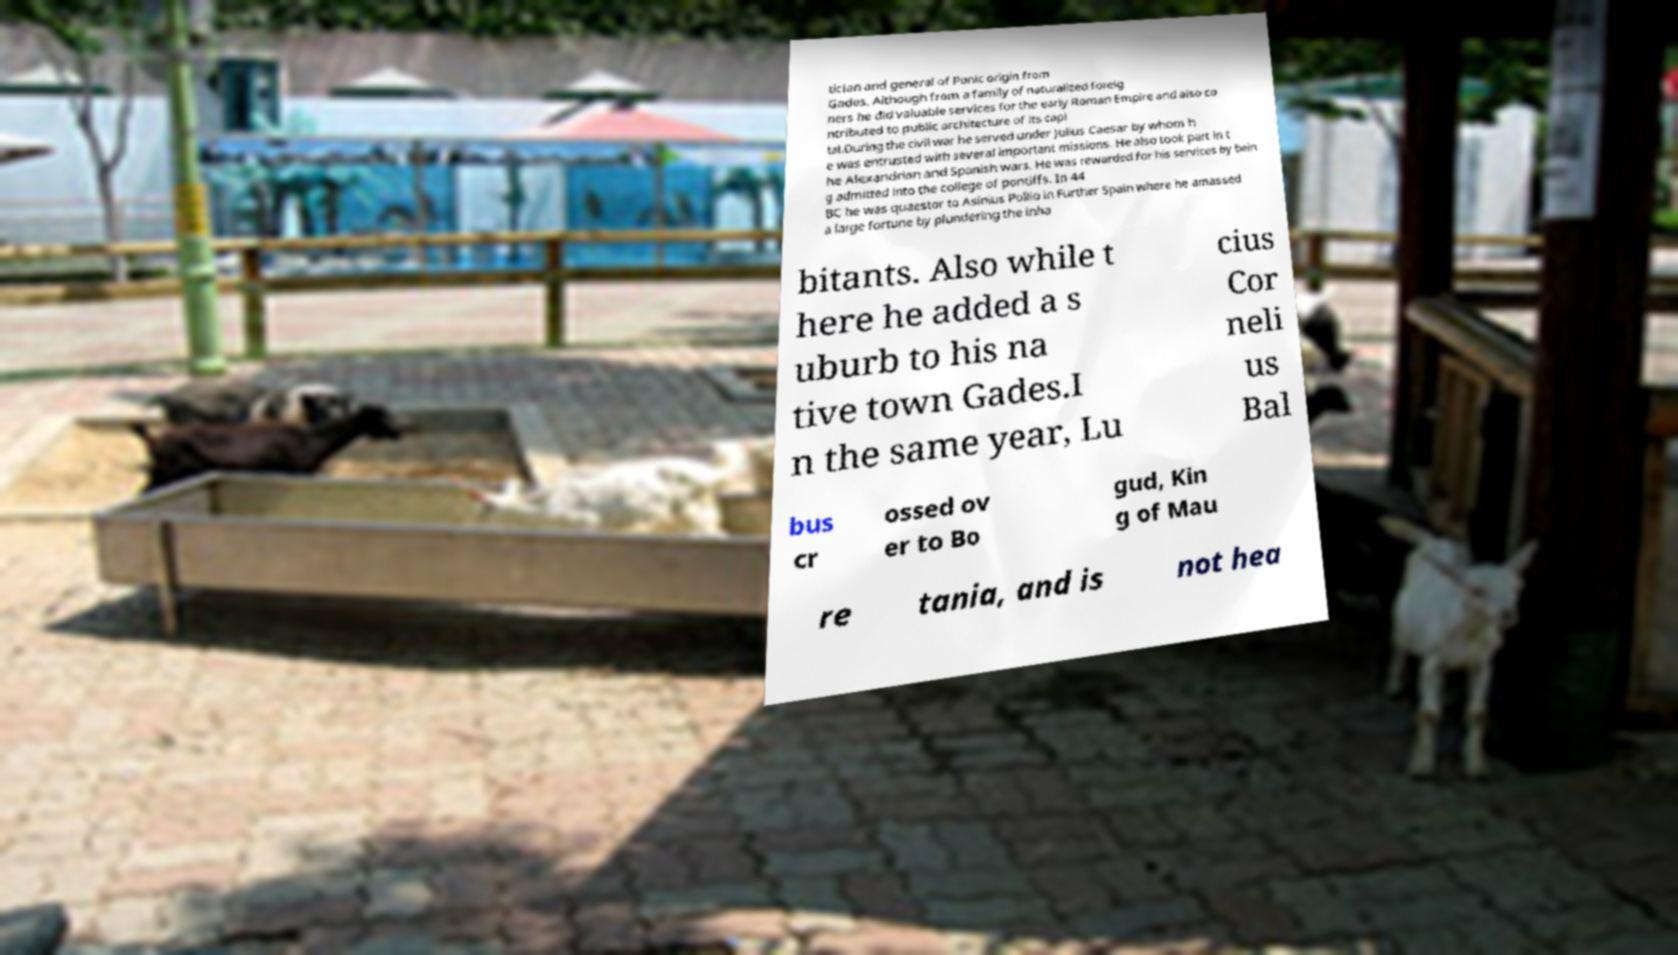Could you assist in decoding the text presented in this image and type it out clearly? tician and general of Punic origin from Gades. Although from a family of naturalized foreig ners he did valuable services for the early Roman Empire and also co ntributed to public architecture of its capi tal.During the civil war he served under Julius Caesar by whom h e was entrusted with several important missions. He also took part in t he Alexandrian and Spanish wars. He was rewarded for his services by bein g admitted into the college of pontiffs. In 44 BC he was quaestor to Asinius Pollio in Further Spain where he amassed a large fortune by plundering the inha bitants. Also while t here he added a s uburb to his na tive town Gades.I n the same year, Lu cius Cor neli us Bal bus cr ossed ov er to Bo gud, Kin g of Mau re tania, and is not hea 